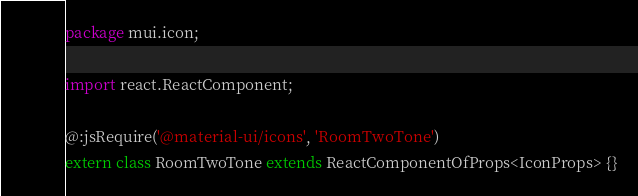<code> <loc_0><loc_0><loc_500><loc_500><_Haxe_>package mui.icon;

import react.ReactComponent;

@:jsRequire('@material-ui/icons', 'RoomTwoTone')
extern class RoomTwoTone extends ReactComponentOfProps<IconProps> {}
</code> 